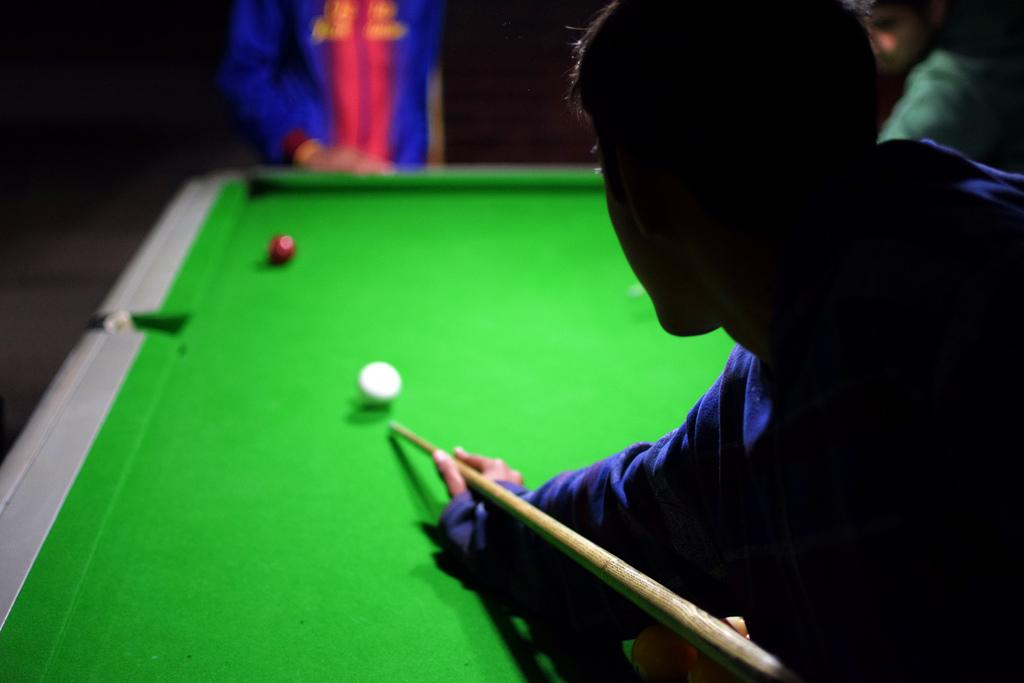How many people are in the image? There are three persons in the image. What is one person holding in the image? One person is holding a cue stick. What can be seen on the table in the image? There are billiard balls on a snooker table. What type of protest is taking place in the image? There is no protest present in the image; it features three people and a snooker table. What kind of marble is used to make the snooker table in the image? The image does not provide information about the materials used to make the snooker table, so it cannot be determined from the image. 